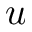<formula> <loc_0><loc_0><loc_500><loc_500>u</formula> 